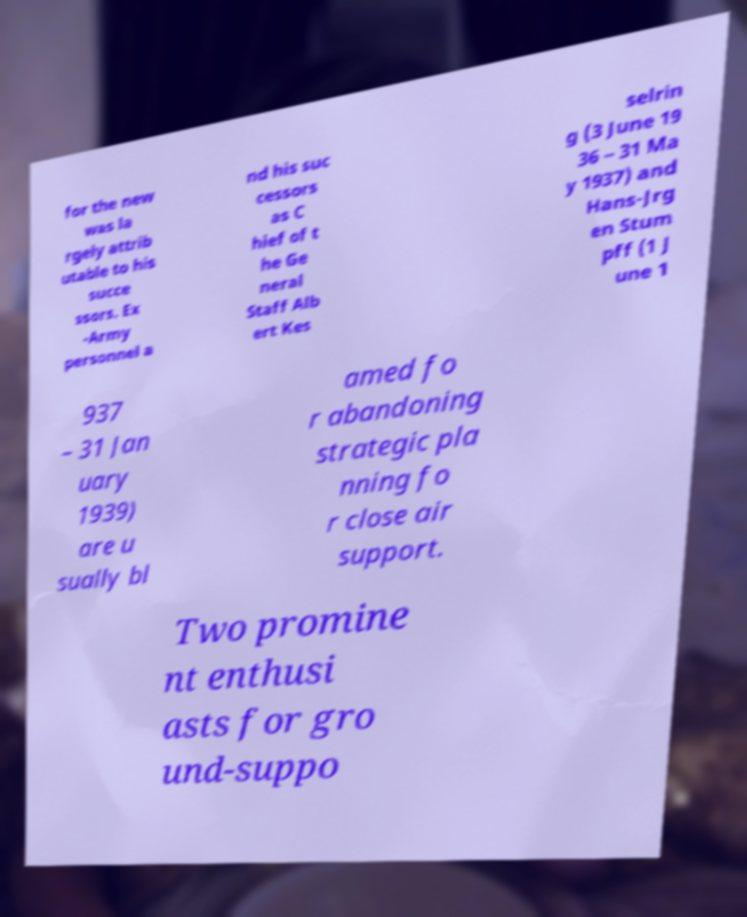There's text embedded in this image that I need extracted. Can you transcribe it verbatim? for the new was la rgely attrib utable to his succe ssors. Ex -Army personnel a nd his suc cessors as C hief of t he Ge neral Staff Alb ert Kes selrin g (3 June 19 36 – 31 Ma y 1937) and Hans-Jrg en Stum pff (1 J une 1 937 – 31 Jan uary 1939) are u sually bl amed fo r abandoning strategic pla nning fo r close air support. Two promine nt enthusi asts for gro und-suppo 